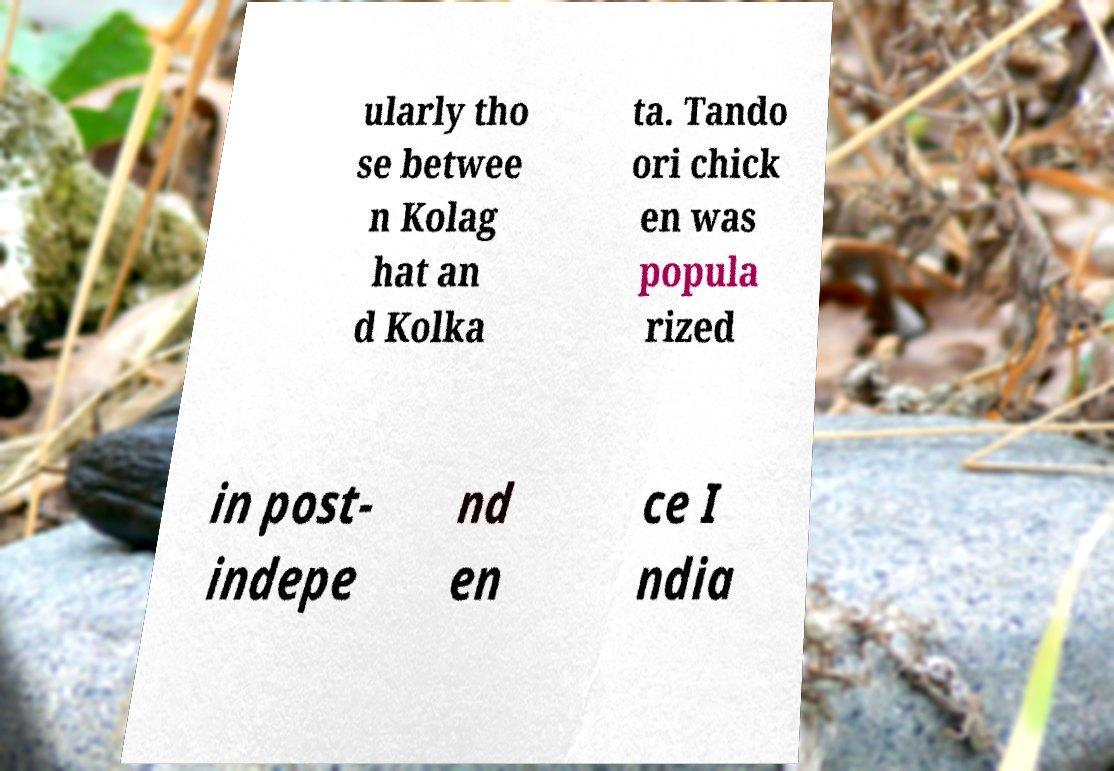For documentation purposes, I need the text within this image transcribed. Could you provide that? ularly tho se betwee n Kolag hat an d Kolka ta. Tando ori chick en was popula rized in post- indepe nd en ce I ndia 